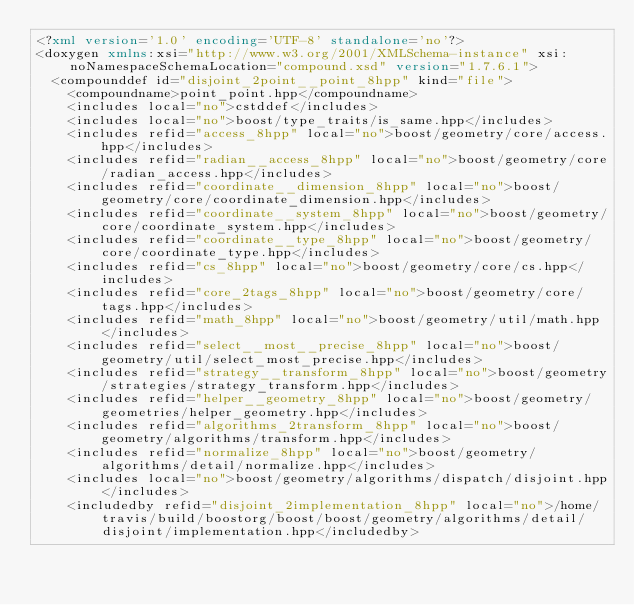<code> <loc_0><loc_0><loc_500><loc_500><_XML_><?xml version='1.0' encoding='UTF-8' standalone='no'?>
<doxygen xmlns:xsi="http://www.w3.org/2001/XMLSchema-instance" xsi:noNamespaceSchemaLocation="compound.xsd" version="1.7.6.1">
  <compounddef id="disjoint_2point__point_8hpp" kind="file">
    <compoundname>point_point.hpp</compoundname>
    <includes local="no">cstddef</includes>
    <includes local="no">boost/type_traits/is_same.hpp</includes>
    <includes refid="access_8hpp" local="no">boost/geometry/core/access.hpp</includes>
    <includes refid="radian__access_8hpp" local="no">boost/geometry/core/radian_access.hpp</includes>
    <includes refid="coordinate__dimension_8hpp" local="no">boost/geometry/core/coordinate_dimension.hpp</includes>
    <includes refid="coordinate__system_8hpp" local="no">boost/geometry/core/coordinate_system.hpp</includes>
    <includes refid="coordinate__type_8hpp" local="no">boost/geometry/core/coordinate_type.hpp</includes>
    <includes refid="cs_8hpp" local="no">boost/geometry/core/cs.hpp</includes>
    <includes refid="core_2tags_8hpp" local="no">boost/geometry/core/tags.hpp</includes>
    <includes refid="math_8hpp" local="no">boost/geometry/util/math.hpp</includes>
    <includes refid="select__most__precise_8hpp" local="no">boost/geometry/util/select_most_precise.hpp</includes>
    <includes refid="strategy__transform_8hpp" local="no">boost/geometry/strategies/strategy_transform.hpp</includes>
    <includes refid="helper__geometry_8hpp" local="no">boost/geometry/geometries/helper_geometry.hpp</includes>
    <includes refid="algorithms_2transform_8hpp" local="no">boost/geometry/algorithms/transform.hpp</includes>
    <includes refid="normalize_8hpp" local="no">boost/geometry/algorithms/detail/normalize.hpp</includes>
    <includes local="no">boost/geometry/algorithms/dispatch/disjoint.hpp</includes>
    <includedby refid="disjoint_2implementation_8hpp" local="no">/home/travis/build/boostorg/boost/boost/geometry/algorithms/detail/disjoint/implementation.hpp</includedby></code> 